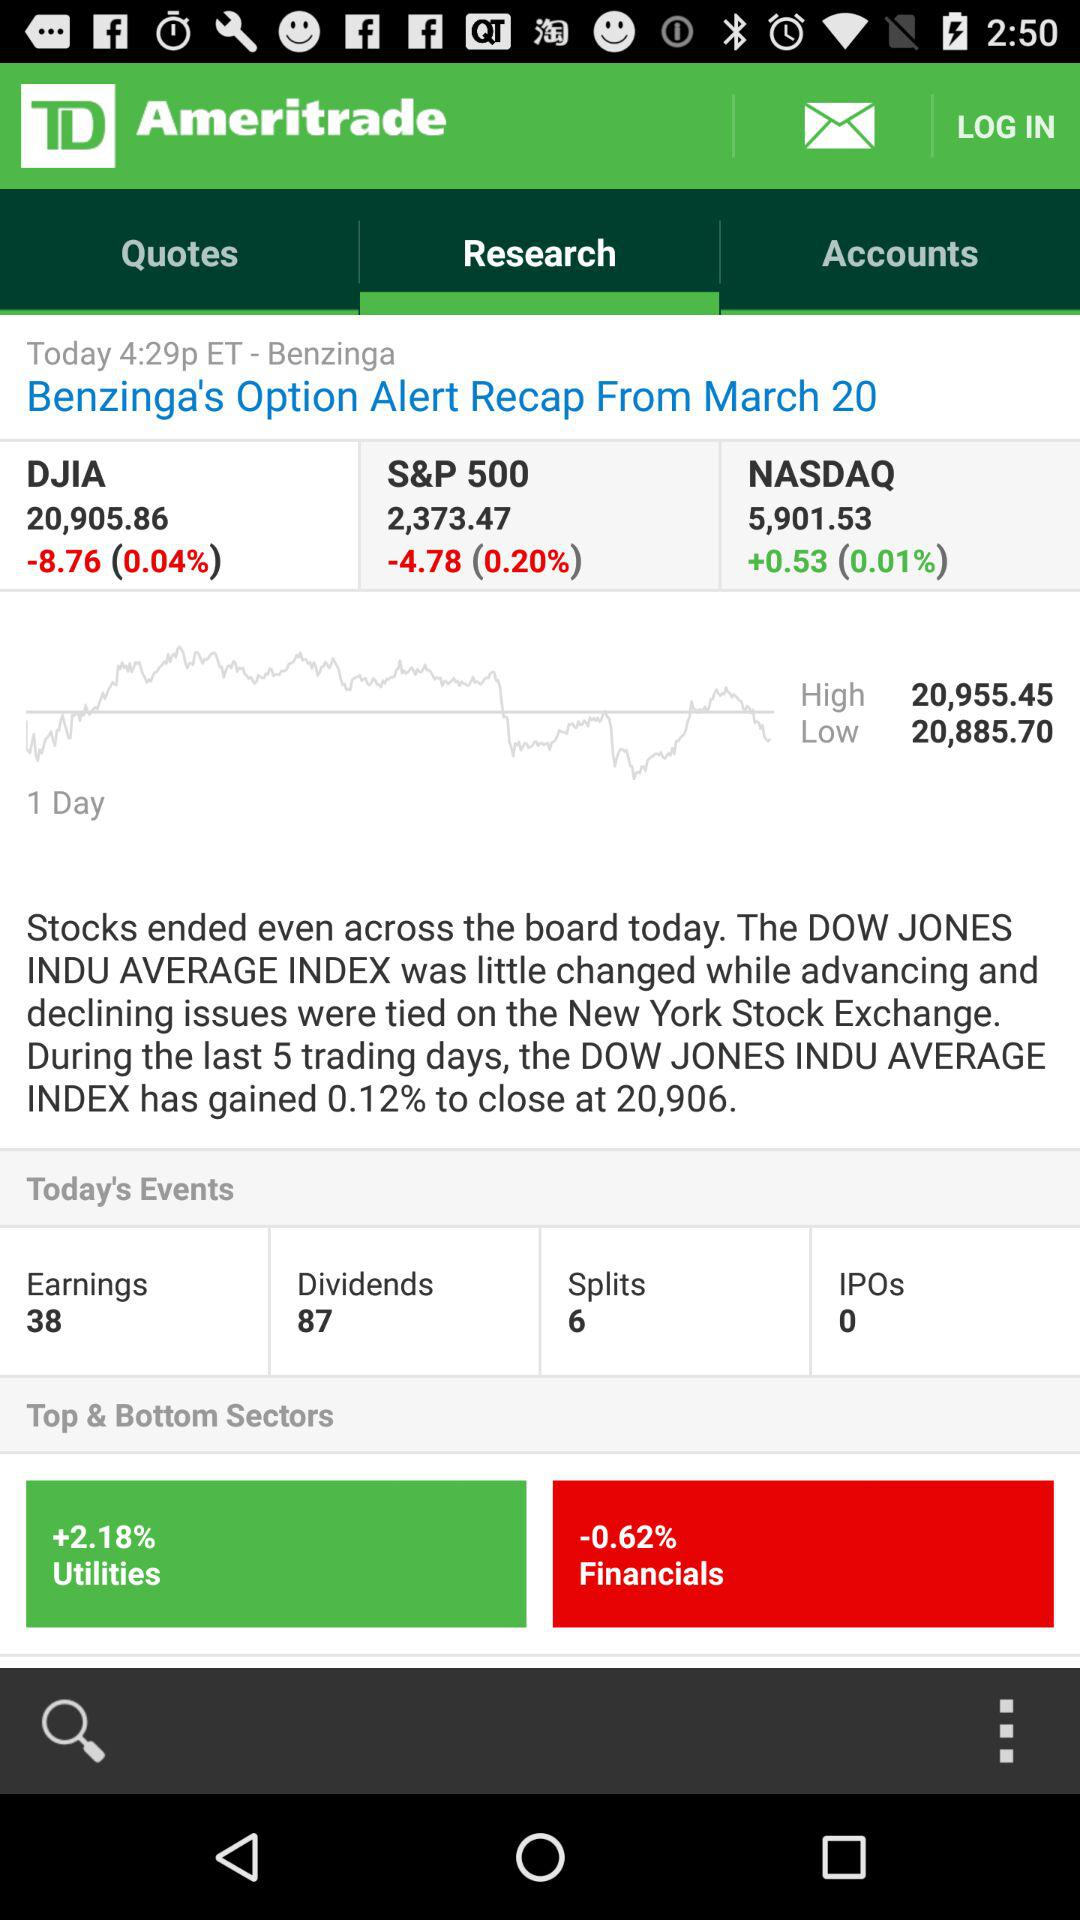What is the percentage of "Financials"? The percentage of financials is -0.62. 